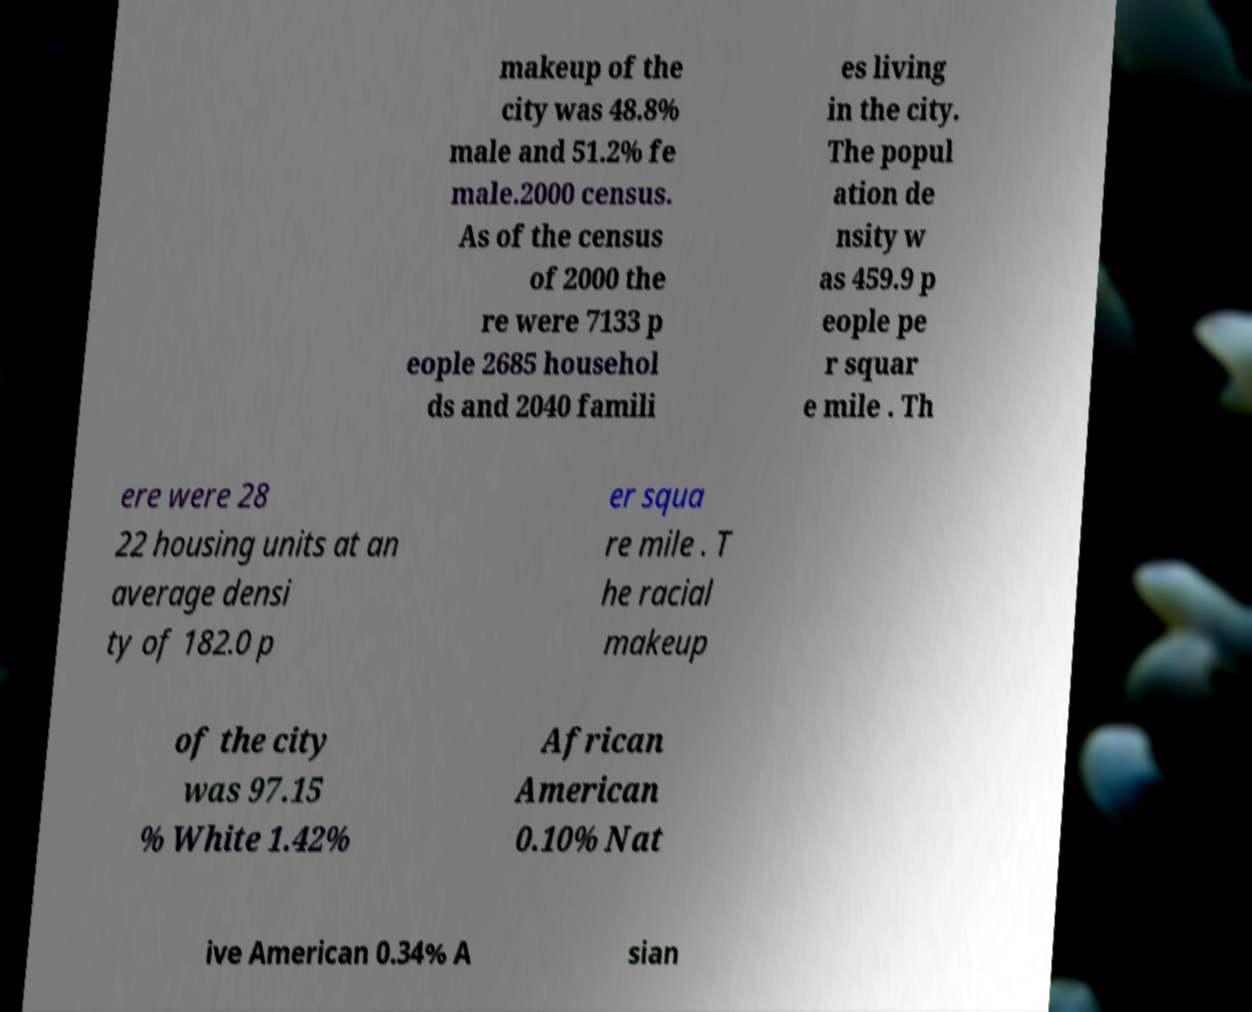Please identify and transcribe the text found in this image. makeup of the city was 48.8% male and 51.2% fe male.2000 census. As of the census of 2000 the re were 7133 p eople 2685 househol ds and 2040 famili es living in the city. The popul ation de nsity w as 459.9 p eople pe r squar e mile . Th ere were 28 22 housing units at an average densi ty of 182.0 p er squa re mile . T he racial makeup of the city was 97.15 % White 1.42% African American 0.10% Nat ive American 0.34% A sian 